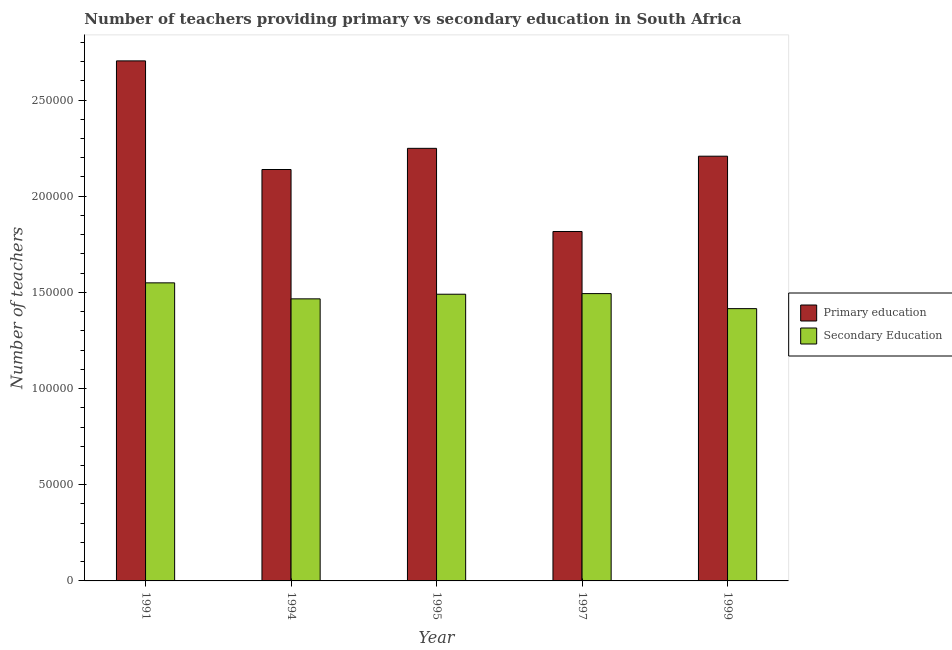Are the number of bars per tick equal to the number of legend labels?
Give a very brief answer. Yes. Are the number of bars on each tick of the X-axis equal?
Make the answer very short. Yes. How many bars are there on the 5th tick from the left?
Keep it short and to the point. 2. What is the label of the 2nd group of bars from the left?
Offer a terse response. 1994. In how many cases, is the number of bars for a given year not equal to the number of legend labels?
Make the answer very short. 0. What is the number of primary teachers in 1997?
Offer a very short reply. 1.82e+05. Across all years, what is the maximum number of secondary teachers?
Offer a terse response. 1.55e+05. Across all years, what is the minimum number of primary teachers?
Offer a terse response. 1.82e+05. In which year was the number of secondary teachers minimum?
Give a very brief answer. 1999. What is the total number of secondary teachers in the graph?
Make the answer very short. 7.42e+05. What is the difference between the number of primary teachers in 1997 and that in 1999?
Keep it short and to the point. -3.91e+04. What is the difference between the number of secondary teachers in 1995 and the number of primary teachers in 1997?
Give a very brief answer. -329. What is the average number of primary teachers per year?
Provide a succinct answer. 2.22e+05. In how many years, is the number of secondary teachers greater than 180000?
Provide a succinct answer. 0. What is the ratio of the number of secondary teachers in 1994 to that in 1997?
Provide a short and direct response. 0.98. Is the number of secondary teachers in 1991 less than that in 1994?
Give a very brief answer. No. What is the difference between the highest and the second highest number of secondary teachers?
Give a very brief answer. 5585. What is the difference between the highest and the lowest number of primary teachers?
Offer a terse response. 8.87e+04. Is the sum of the number of primary teachers in 1991 and 1994 greater than the maximum number of secondary teachers across all years?
Ensure brevity in your answer.  Yes. What does the 1st bar from the left in 1999 represents?
Your answer should be compact. Primary education. What does the 1st bar from the right in 1997 represents?
Keep it short and to the point. Secondary Education. How many years are there in the graph?
Give a very brief answer. 5. Are the values on the major ticks of Y-axis written in scientific E-notation?
Make the answer very short. No. Does the graph contain any zero values?
Keep it short and to the point. No. Where does the legend appear in the graph?
Ensure brevity in your answer.  Center right. What is the title of the graph?
Your response must be concise. Number of teachers providing primary vs secondary education in South Africa. What is the label or title of the Y-axis?
Your answer should be very brief. Number of teachers. What is the Number of teachers of Primary education in 1991?
Provide a short and direct response. 2.70e+05. What is the Number of teachers in Secondary Education in 1991?
Your response must be concise. 1.55e+05. What is the Number of teachers of Primary education in 1994?
Provide a short and direct response. 2.14e+05. What is the Number of teachers of Secondary Education in 1994?
Offer a terse response. 1.47e+05. What is the Number of teachers in Primary education in 1995?
Your answer should be very brief. 2.25e+05. What is the Number of teachers in Secondary Education in 1995?
Your answer should be compact. 1.49e+05. What is the Number of teachers in Primary education in 1997?
Provide a short and direct response. 1.82e+05. What is the Number of teachers of Secondary Education in 1997?
Keep it short and to the point. 1.49e+05. What is the Number of teachers in Primary education in 1999?
Give a very brief answer. 2.21e+05. What is the Number of teachers in Secondary Education in 1999?
Make the answer very short. 1.42e+05. Across all years, what is the maximum Number of teachers in Primary education?
Give a very brief answer. 2.70e+05. Across all years, what is the maximum Number of teachers in Secondary Education?
Your answer should be compact. 1.55e+05. Across all years, what is the minimum Number of teachers in Primary education?
Your response must be concise. 1.82e+05. Across all years, what is the minimum Number of teachers in Secondary Education?
Your answer should be compact. 1.42e+05. What is the total Number of teachers in Primary education in the graph?
Keep it short and to the point. 1.11e+06. What is the total Number of teachers in Secondary Education in the graph?
Keep it short and to the point. 7.42e+05. What is the difference between the Number of teachers of Primary education in 1991 and that in 1994?
Make the answer very short. 5.65e+04. What is the difference between the Number of teachers in Secondary Education in 1991 and that in 1994?
Your answer should be very brief. 8317. What is the difference between the Number of teachers of Primary education in 1991 and that in 1995?
Offer a very short reply. 4.55e+04. What is the difference between the Number of teachers in Secondary Education in 1991 and that in 1995?
Provide a short and direct response. 5914. What is the difference between the Number of teachers in Primary education in 1991 and that in 1997?
Offer a terse response. 8.87e+04. What is the difference between the Number of teachers in Secondary Education in 1991 and that in 1997?
Make the answer very short. 5585. What is the difference between the Number of teachers in Primary education in 1991 and that in 1999?
Your answer should be compact. 4.96e+04. What is the difference between the Number of teachers of Secondary Education in 1991 and that in 1999?
Your answer should be compact. 1.34e+04. What is the difference between the Number of teachers in Primary education in 1994 and that in 1995?
Provide a succinct answer. -1.10e+04. What is the difference between the Number of teachers of Secondary Education in 1994 and that in 1995?
Offer a very short reply. -2403. What is the difference between the Number of teachers of Primary education in 1994 and that in 1997?
Provide a succinct answer. 3.22e+04. What is the difference between the Number of teachers of Secondary Education in 1994 and that in 1997?
Provide a short and direct response. -2732. What is the difference between the Number of teachers of Primary education in 1994 and that in 1999?
Your answer should be compact. -6923. What is the difference between the Number of teachers in Secondary Education in 1994 and that in 1999?
Keep it short and to the point. 5081. What is the difference between the Number of teachers of Primary education in 1995 and that in 1997?
Provide a short and direct response. 4.32e+04. What is the difference between the Number of teachers in Secondary Education in 1995 and that in 1997?
Your answer should be very brief. -329. What is the difference between the Number of teachers in Primary education in 1995 and that in 1999?
Provide a succinct answer. 4083. What is the difference between the Number of teachers of Secondary Education in 1995 and that in 1999?
Give a very brief answer. 7484. What is the difference between the Number of teachers of Primary education in 1997 and that in 1999?
Make the answer very short. -3.91e+04. What is the difference between the Number of teachers in Secondary Education in 1997 and that in 1999?
Offer a terse response. 7813. What is the difference between the Number of teachers in Primary education in 1991 and the Number of teachers in Secondary Education in 1994?
Your answer should be very brief. 1.24e+05. What is the difference between the Number of teachers in Primary education in 1991 and the Number of teachers in Secondary Education in 1995?
Give a very brief answer. 1.21e+05. What is the difference between the Number of teachers in Primary education in 1991 and the Number of teachers in Secondary Education in 1997?
Offer a very short reply. 1.21e+05. What is the difference between the Number of teachers of Primary education in 1991 and the Number of teachers of Secondary Education in 1999?
Your response must be concise. 1.29e+05. What is the difference between the Number of teachers in Primary education in 1994 and the Number of teachers in Secondary Education in 1995?
Provide a short and direct response. 6.48e+04. What is the difference between the Number of teachers of Primary education in 1994 and the Number of teachers of Secondary Education in 1997?
Your answer should be compact. 6.45e+04. What is the difference between the Number of teachers of Primary education in 1994 and the Number of teachers of Secondary Education in 1999?
Provide a short and direct response. 7.23e+04. What is the difference between the Number of teachers of Primary education in 1995 and the Number of teachers of Secondary Education in 1997?
Your answer should be compact. 7.55e+04. What is the difference between the Number of teachers of Primary education in 1995 and the Number of teachers of Secondary Education in 1999?
Your answer should be compact. 8.33e+04. What is the difference between the Number of teachers in Primary education in 1997 and the Number of teachers in Secondary Education in 1999?
Offer a terse response. 4.01e+04. What is the average Number of teachers in Primary education per year?
Ensure brevity in your answer.  2.22e+05. What is the average Number of teachers of Secondary Education per year?
Your answer should be compact. 1.48e+05. In the year 1991, what is the difference between the Number of teachers of Primary education and Number of teachers of Secondary Education?
Offer a very short reply. 1.15e+05. In the year 1994, what is the difference between the Number of teachers of Primary education and Number of teachers of Secondary Education?
Make the answer very short. 6.72e+04. In the year 1995, what is the difference between the Number of teachers in Primary education and Number of teachers in Secondary Education?
Make the answer very short. 7.58e+04. In the year 1997, what is the difference between the Number of teachers in Primary education and Number of teachers in Secondary Education?
Offer a very short reply. 3.23e+04. In the year 1999, what is the difference between the Number of teachers of Primary education and Number of teachers of Secondary Education?
Your response must be concise. 7.93e+04. What is the ratio of the Number of teachers in Primary education in 1991 to that in 1994?
Your response must be concise. 1.26. What is the ratio of the Number of teachers of Secondary Education in 1991 to that in 1994?
Your answer should be compact. 1.06. What is the ratio of the Number of teachers of Primary education in 1991 to that in 1995?
Provide a succinct answer. 1.2. What is the ratio of the Number of teachers of Secondary Education in 1991 to that in 1995?
Your answer should be very brief. 1.04. What is the ratio of the Number of teachers of Primary education in 1991 to that in 1997?
Offer a terse response. 1.49. What is the ratio of the Number of teachers of Secondary Education in 1991 to that in 1997?
Keep it short and to the point. 1.04. What is the ratio of the Number of teachers of Primary education in 1991 to that in 1999?
Provide a succinct answer. 1.22. What is the ratio of the Number of teachers in Secondary Education in 1991 to that in 1999?
Keep it short and to the point. 1.09. What is the ratio of the Number of teachers in Primary education in 1994 to that in 1995?
Ensure brevity in your answer.  0.95. What is the ratio of the Number of teachers of Secondary Education in 1994 to that in 1995?
Your answer should be compact. 0.98. What is the ratio of the Number of teachers in Primary education in 1994 to that in 1997?
Give a very brief answer. 1.18. What is the ratio of the Number of teachers in Secondary Education in 1994 to that in 1997?
Keep it short and to the point. 0.98. What is the ratio of the Number of teachers in Primary education in 1994 to that in 1999?
Your response must be concise. 0.97. What is the ratio of the Number of teachers in Secondary Education in 1994 to that in 1999?
Give a very brief answer. 1.04. What is the ratio of the Number of teachers in Primary education in 1995 to that in 1997?
Provide a succinct answer. 1.24. What is the ratio of the Number of teachers in Secondary Education in 1995 to that in 1997?
Keep it short and to the point. 1. What is the ratio of the Number of teachers of Primary education in 1995 to that in 1999?
Give a very brief answer. 1.02. What is the ratio of the Number of teachers in Secondary Education in 1995 to that in 1999?
Offer a terse response. 1.05. What is the ratio of the Number of teachers in Primary education in 1997 to that in 1999?
Keep it short and to the point. 0.82. What is the ratio of the Number of teachers in Secondary Education in 1997 to that in 1999?
Make the answer very short. 1.06. What is the difference between the highest and the second highest Number of teachers in Primary education?
Offer a very short reply. 4.55e+04. What is the difference between the highest and the second highest Number of teachers in Secondary Education?
Provide a succinct answer. 5585. What is the difference between the highest and the lowest Number of teachers in Primary education?
Offer a very short reply. 8.87e+04. What is the difference between the highest and the lowest Number of teachers of Secondary Education?
Give a very brief answer. 1.34e+04. 